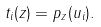<formula> <loc_0><loc_0><loc_500><loc_500>t _ { i } ( z ) = p _ { z } ( u _ { i } ) .</formula> 